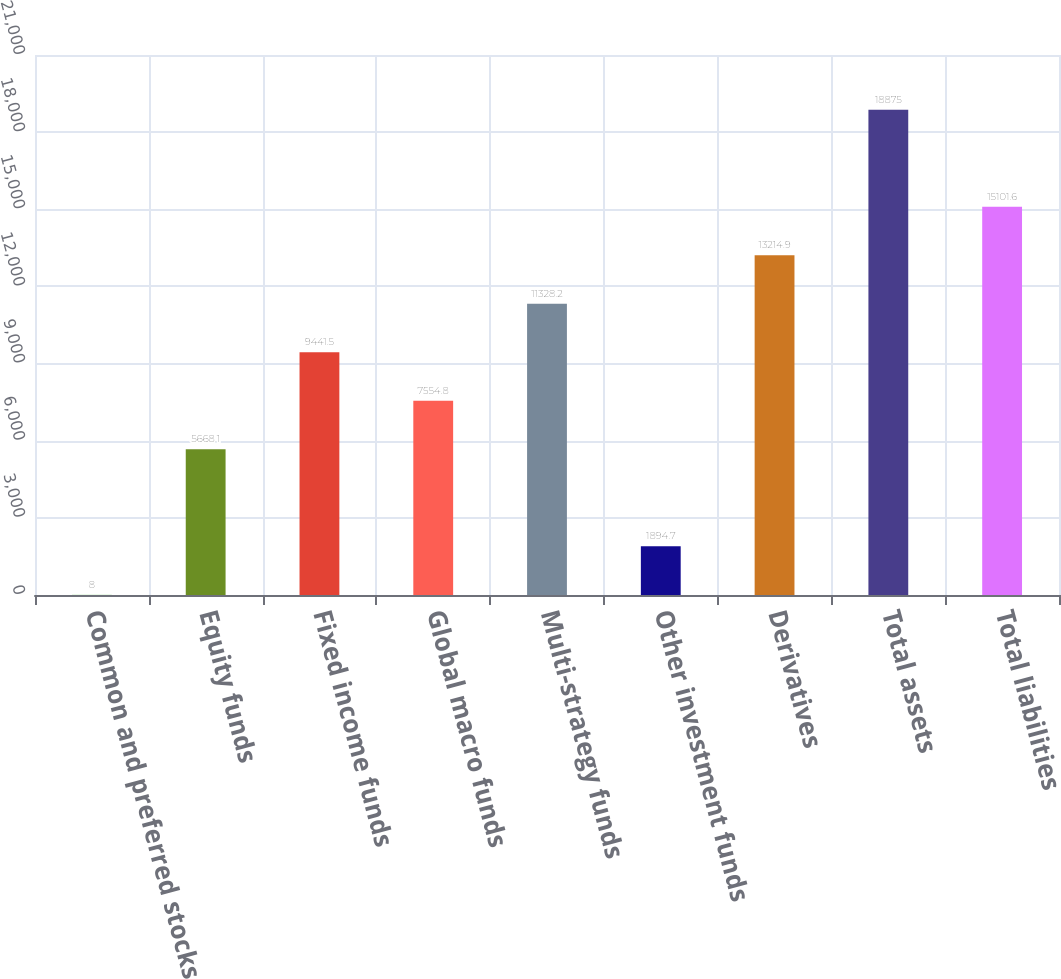<chart> <loc_0><loc_0><loc_500><loc_500><bar_chart><fcel>Common and preferred stocks<fcel>Equity funds<fcel>Fixed income funds<fcel>Global macro funds<fcel>Multi-strategy funds<fcel>Other investment funds<fcel>Derivatives<fcel>Total assets<fcel>Total liabilities<nl><fcel>8<fcel>5668.1<fcel>9441.5<fcel>7554.8<fcel>11328.2<fcel>1894.7<fcel>13214.9<fcel>18875<fcel>15101.6<nl></chart> 